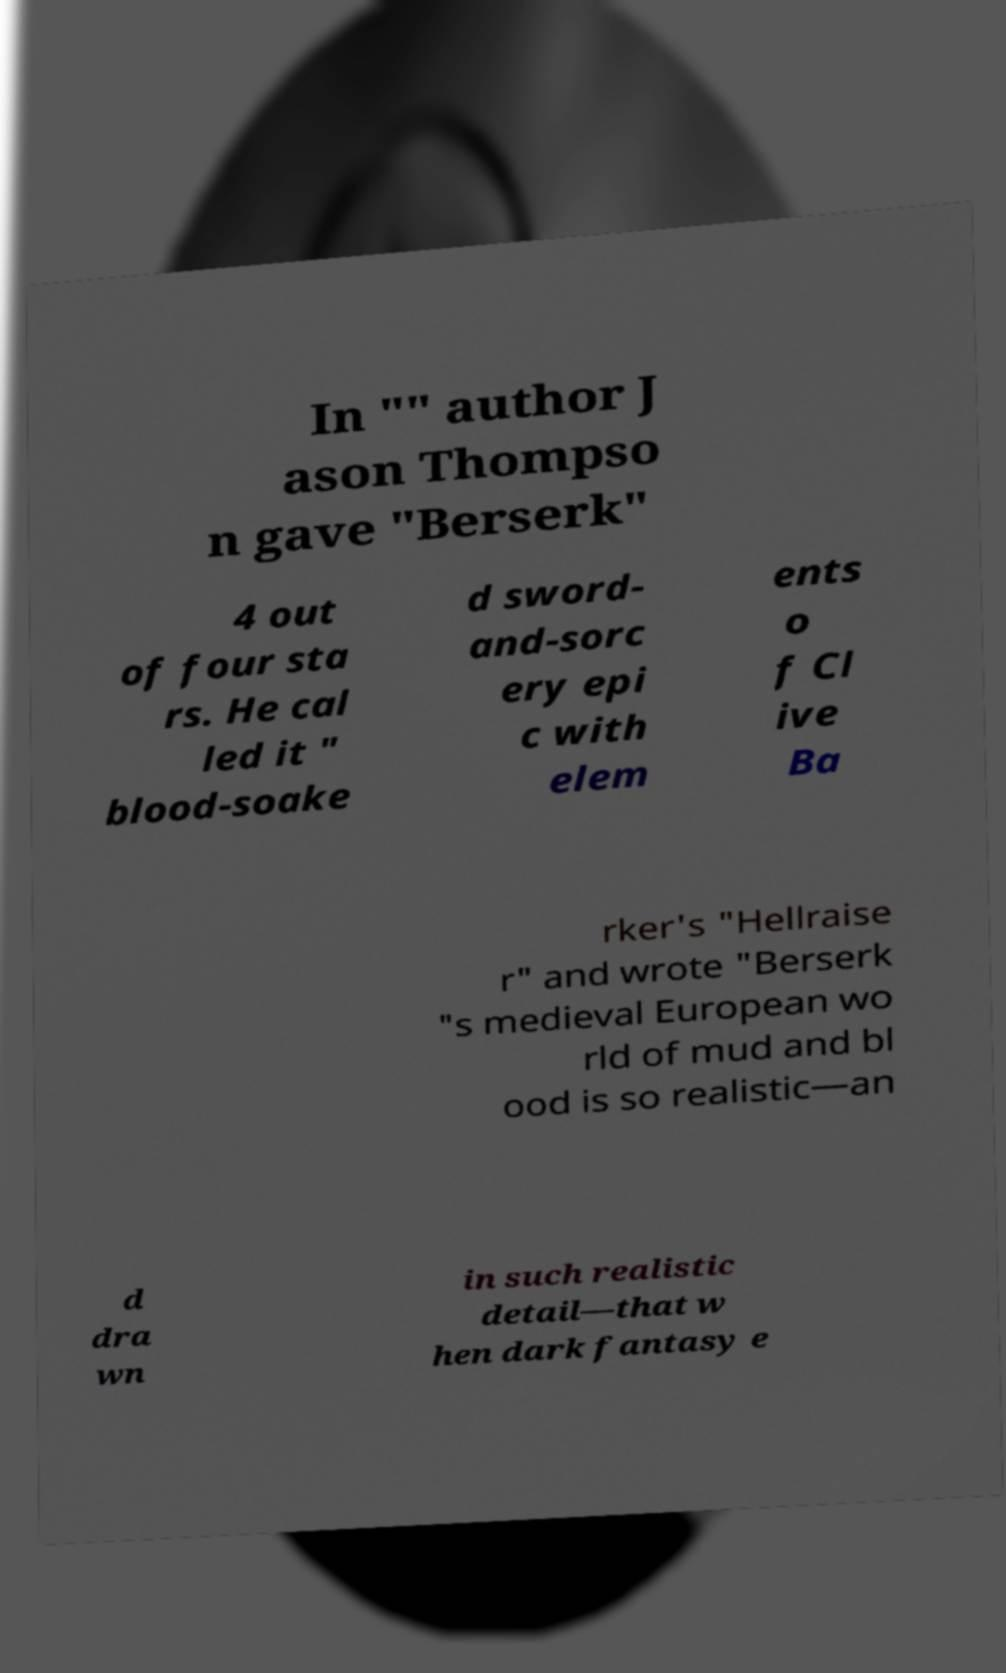Could you assist in decoding the text presented in this image and type it out clearly? In "" author J ason Thompso n gave "Berserk" 4 out of four sta rs. He cal led it " blood-soake d sword- and-sorc ery epi c with elem ents o f Cl ive Ba rker's "Hellraise r" and wrote "Berserk "s medieval European wo rld of mud and bl ood is so realistic—an d dra wn in such realistic detail—that w hen dark fantasy e 